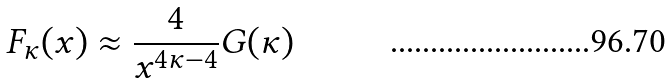<formula> <loc_0><loc_0><loc_500><loc_500>F _ { \kappa } ( x ) \approx \frac { 4 } { x ^ { 4 \kappa - 4 } } G ( \kappa )</formula> 